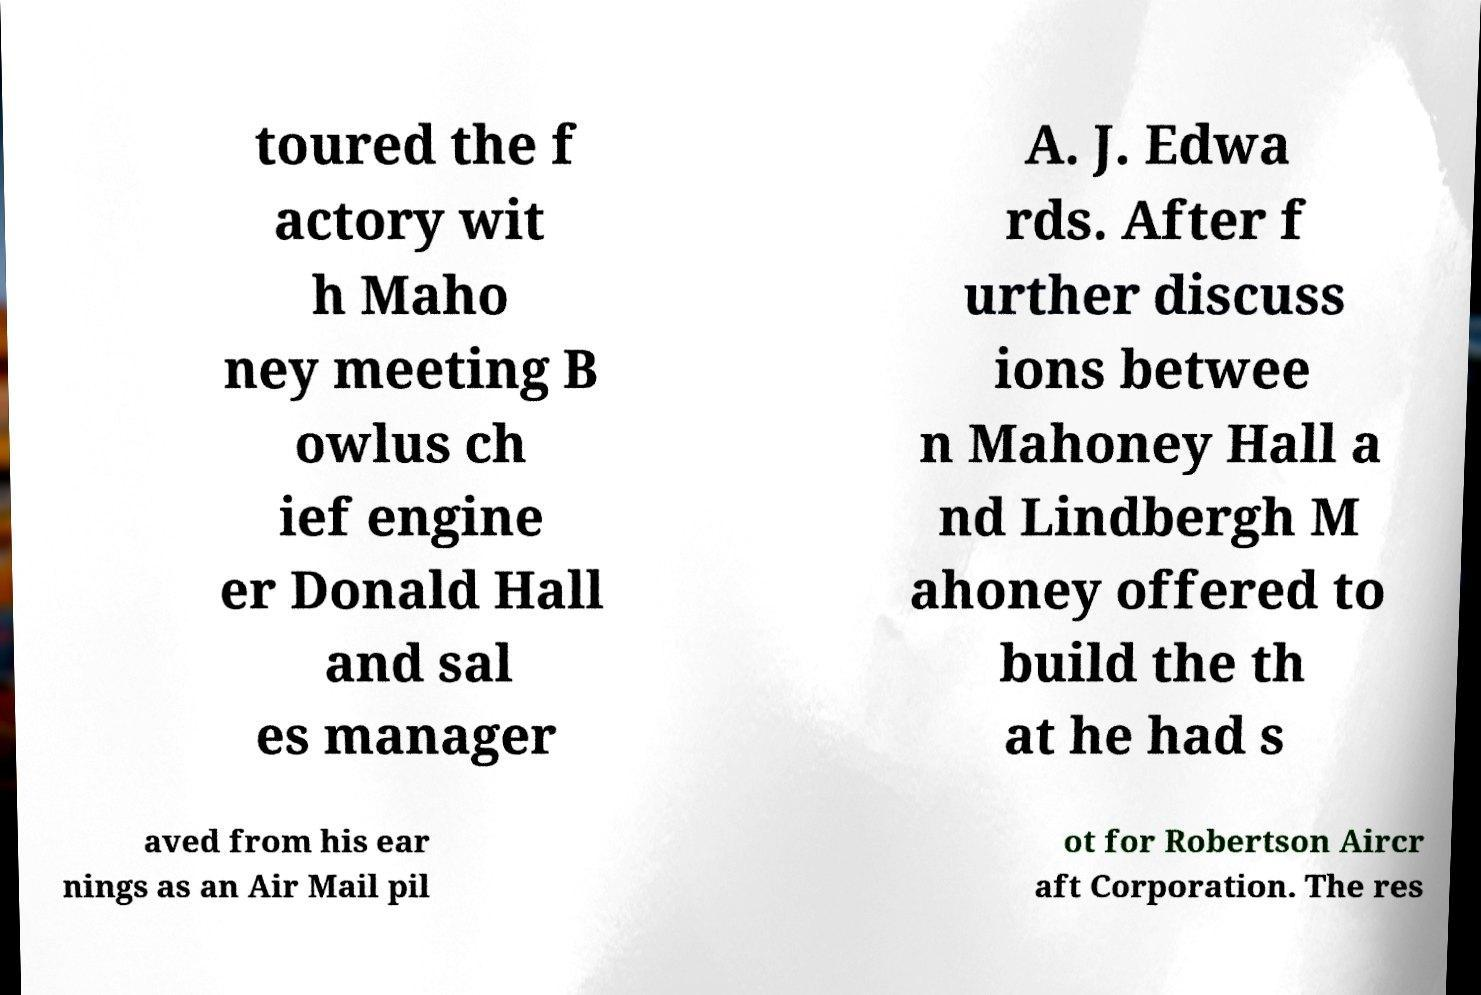Please read and relay the text visible in this image. What does it say? toured the f actory wit h Maho ney meeting B owlus ch ief engine er Donald Hall and sal es manager A. J. Edwa rds. After f urther discuss ions betwee n Mahoney Hall a nd Lindbergh M ahoney offered to build the th at he had s aved from his ear nings as an Air Mail pil ot for Robertson Aircr aft Corporation. The res 